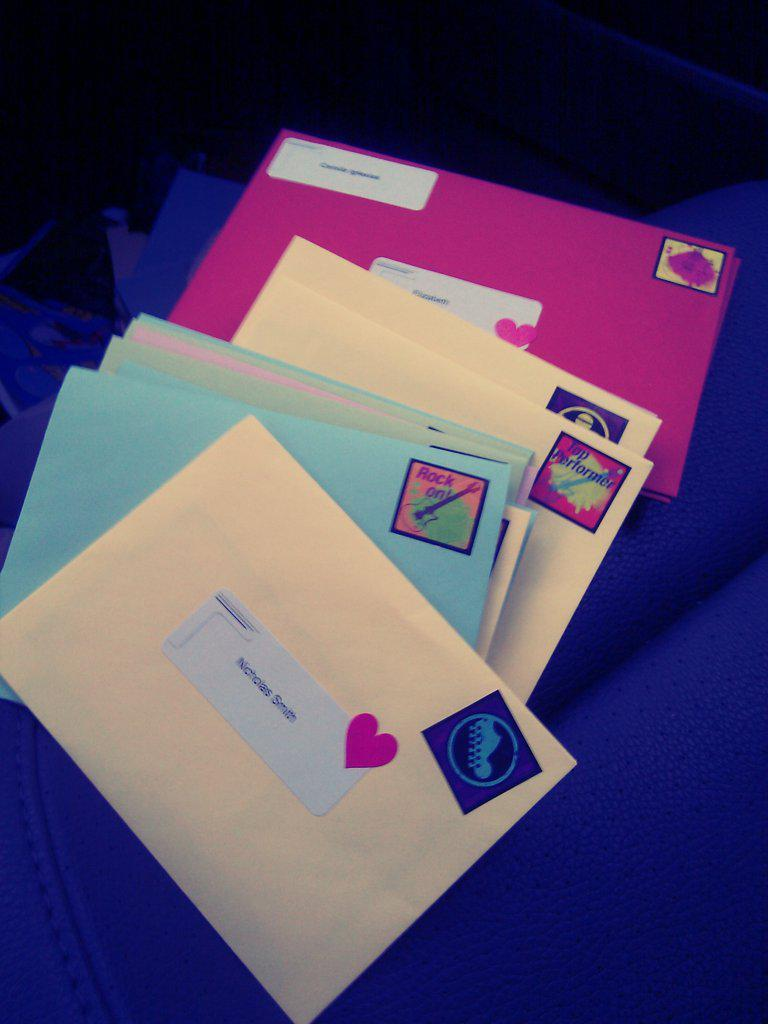Provide a one-sentence caption for the provided image. A pile of brightly colored unopened letters are resting on a surface. 